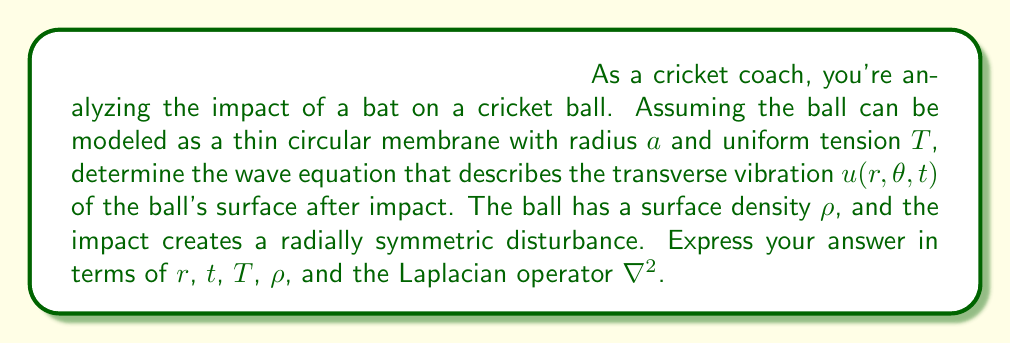Help me with this question. To derive the wave equation for the vibration of a cricket ball upon impact with a bat, we need to consider the following steps:

1) The cricket ball's surface can be modeled as a thin circular membrane. In polar coordinates, the Laplacian operator is given by:

   $$\nabla^2 = \frac{\partial^2}{\partial r^2} + \frac{1}{r}\frac{\partial}{\partial r} + \frac{1}{r^2}\frac{\partial^2}{\partial \theta^2}$$

2) Since the impact creates a radially symmetric disturbance, the vibration doesn't depend on $\theta$. Therefore, $\frac{\partial^2 u}{\partial \theta^2} = 0$, and we can simplify the Laplacian to:

   $$\nabla^2 u = \frac{\partial^2 u}{\partial r^2} + \frac{1}{r}\frac{\partial u}{\partial r}$$

3) The general form of the wave equation in two dimensions is:

   $$\frac{\partial^2 u}{\partial t^2} = c^2 \nabla^2 u$$

   where $c$ is the wave speed.

4) For a membrane with uniform tension $T$ and surface density $\rho$, the wave speed is given by:

   $$c = \sqrt{\frac{T}{\rho}}$$

5) Substituting this into the wave equation:

   $$\frac{\partial^2 u}{\partial t^2} = \frac{T}{\rho} \nabla^2 u$$

6) Expanding the Laplacian using the radially symmetric form:

   $$\frac{\partial^2 u}{\partial t^2} = \frac{T}{\rho} \left(\frac{\partial^2 u}{\partial r^2} + \frac{1}{r}\frac{\partial u}{\partial r}\right)$$

This is the wave equation describing the transverse vibration of the cricket ball's surface after impact with the bat.
Answer: $$\frac{\partial^2 u}{\partial t^2} = \frac{T}{\rho} \nabla^2 u$$
where $\nabla^2 u = \frac{\partial^2 u}{\partial r^2} + \frac{1}{r}\frac{\partial u}{\partial r}$ 